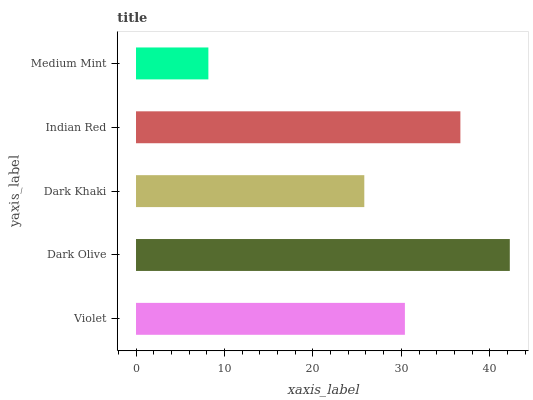Is Medium Mint the minimum?
Answer yes or no. Yes. Is Dark Olive the maximum?
Answer yes or no. Yes. Is Dark Khaki the minimum?
Answer yes or no. No. Is Dark Khaki the maximum?
Answer yes or no. No. Is Dark Olive greater than Dark Khaki?
Answer yes or no. Yes. Is Dark Khaki less than Dark Olive?
Answer yes or no. Yes. Is Dark Khaki greater than Dark Olive?
Answer yes or no. No. Is Dark Olive less than Dark Khaki?
Answer yes or no. No. Is Violet the high median?
Answer yes or no. Yes. Is Violet the low median?
Answer yes or no. Yes. Is Medium Mint the high median?
Answer yes or no. No. Is Medium Mint the low median?
Answer yes or no. No. 